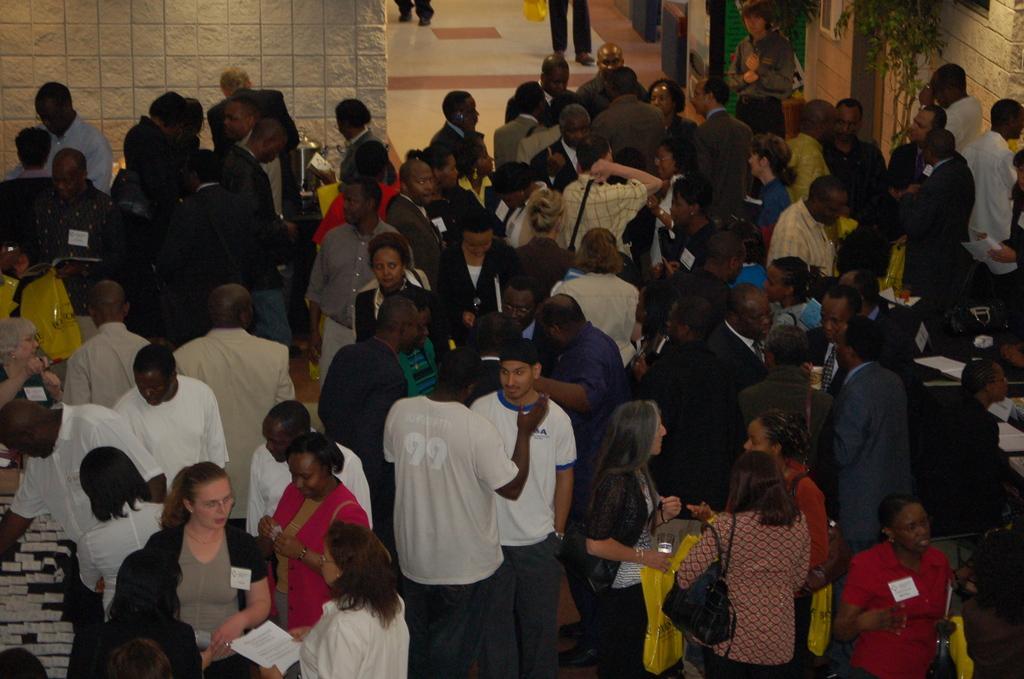Please provide a concise description of this image. In the picture I can see group of people are standing on the floor and holding some objects in hands. In the background I can see a wall and some other objects. 